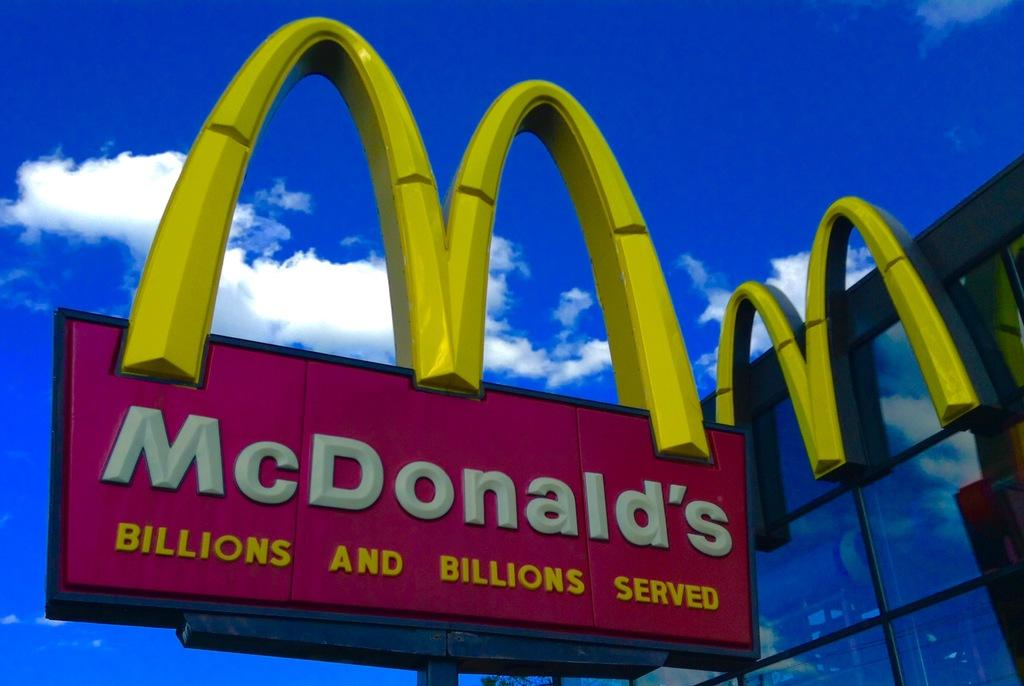Provide a one-sentence caption for the provided image. A McDonald's sign out next to a building with lots of glass windows. 